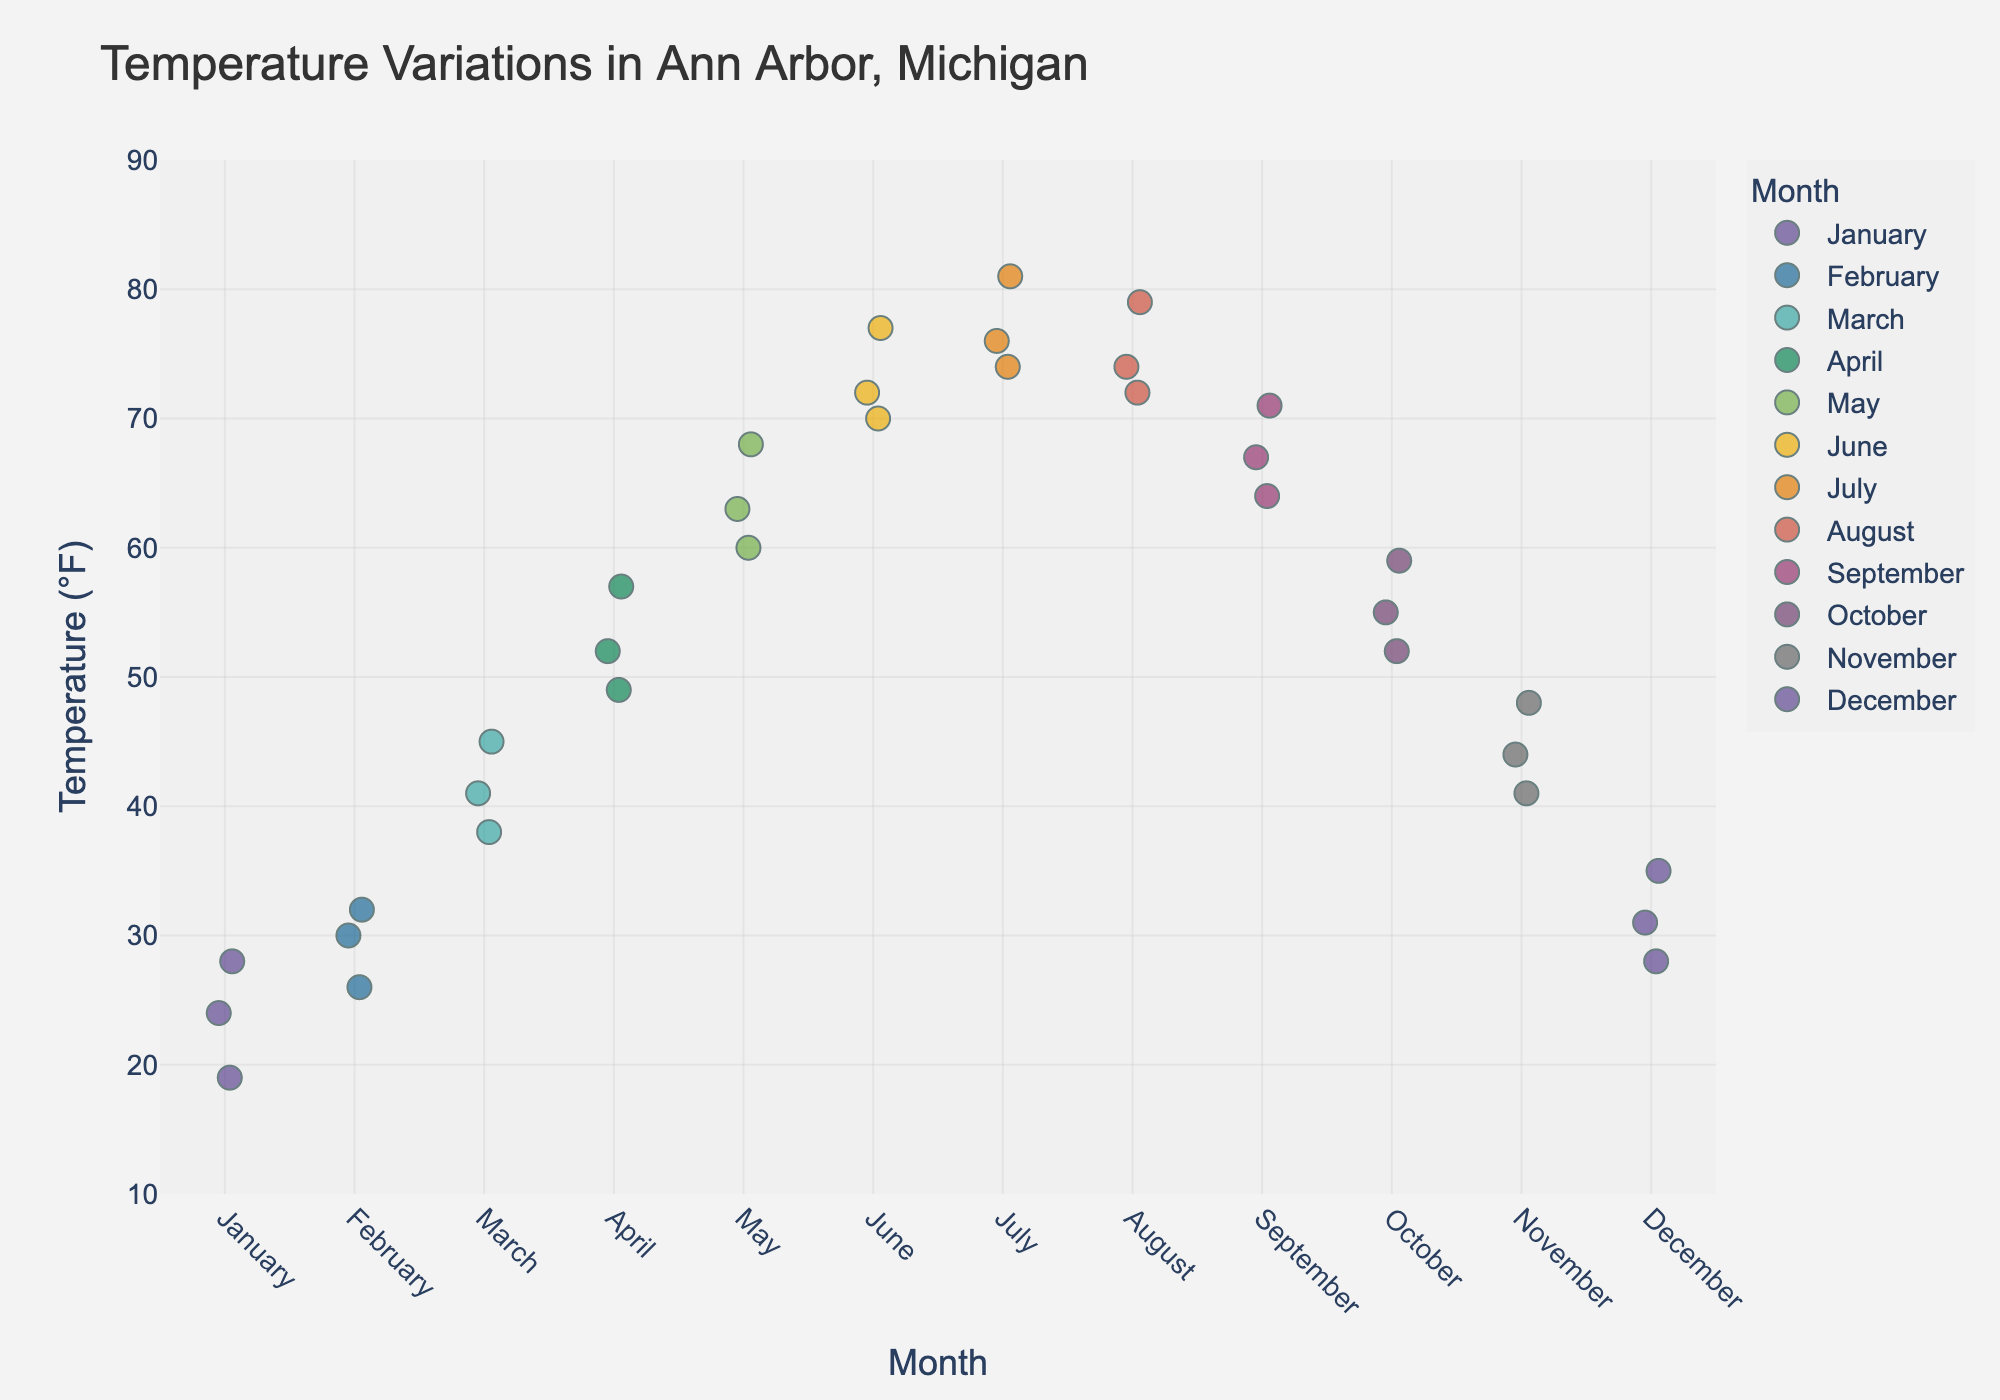what is the title of the figure? The title of the figure is usually placed at the top of the plot and is intended to provide a summary of what the plot is about. In this case, the title "Temperature Variations in Ann Arbor, Michigan" is displayed prominently at the top of the figure.
Answer: Temperature Variations in Ann Arbor, Michigan what are the x-axis and y-axis representing? The x-axis (horizontal axis) usually represents the categories, while the y-axis (vertical axis) represents the values. In this plot, the x-axis represents the "Month" and the y-axis represents the "Temperature (°F)".
Answer: Months, Temperature (°F) which month shows the highest recorded temperature and what is that temperature? By closely examining the scatter of points for each month along the y-axis, we find that July shows the highest recorded temperature at 81°F.
Answer: July, 81°F On average, does May have a higher temperature than September? To find this, compare the average temperature points for May and September. Noticing that May has temperatures of (63, 68, 60) with an average of (63+68+60)/3 = 63.67°F and September has (67, 71, 64) with an average of (67+71+64)/3 = 67.33°F. September has a higher average temperature.
Answer: No, September does which months have temperatures falling within the range of 70°F to 80°F? By identifying the months where data points fall within the y-axis range of 70°F to 80°F, we see that June, July, August, and September have temperatures in this range.
Answer: June, July, August, September which month has the most dispersed temperature values? By observing the spread of points for each month, identify which month has the widest range of values along the y-axis. January has a large dispersion in temperatures ranging from 19°F to 28°F.
Answer: January do March and November have overlapping temperature ranges? By comparing the temperature ranges, March ranges from 38°F to 45°F, and November ranges from 41°F to 48°F. These ranges overlap from 41°F to 45°F.
Answer: Yes what is the median temperature for October? The median value is the middle number of a sorted, ascending dataset. For October, the temperatures are (52, 55, 59). Since there are three data points, the median value is the second number, which is 55.
Answer: 55°F is there a noticeable trend in temperature from January to December? By observing the pattern of the temperature values from January to December, one can observe an upward trend in temperature from winter to summer and then a downward trend toward winter.
Answer: Yes which month has the least variation in temperature? The month with the least variation will have data points closest together. December appears to have closely clustered points around 28°F, 31°F, and 35°F, indicating the least variation.
Answer: December 